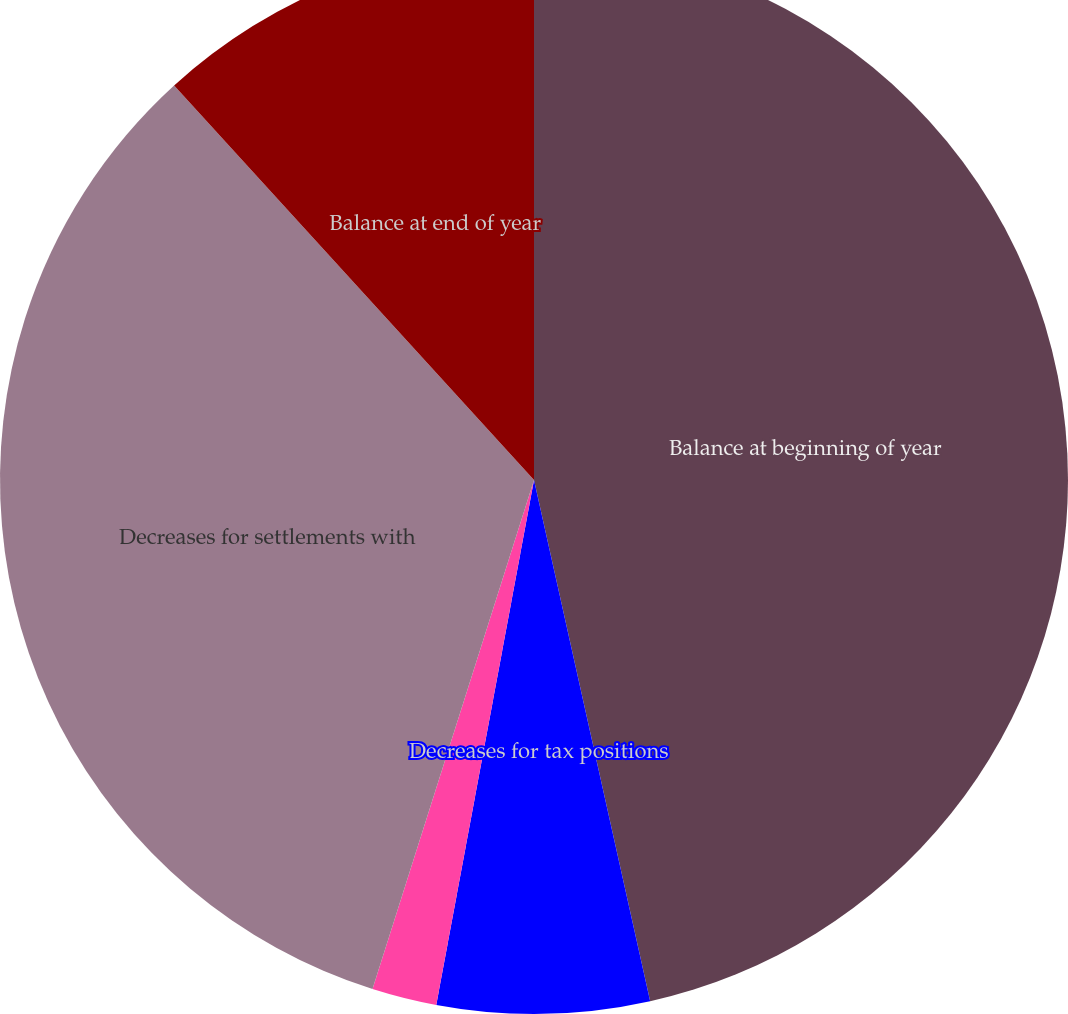<chart> <loc_0><loc_0><loc_500><loc_500><pie_chart><fcel>Balance at beginning of year<fcel>Decreases for tax positions<fcel>Increases for tax positions<fcel>Decreases for settlements with<fcel>Balance at end of year<nl><fcel>46.51%<fcel>6.42%<fcel>1.96%<fcel>33.34%<fcel>11.77%<nl></chart> 